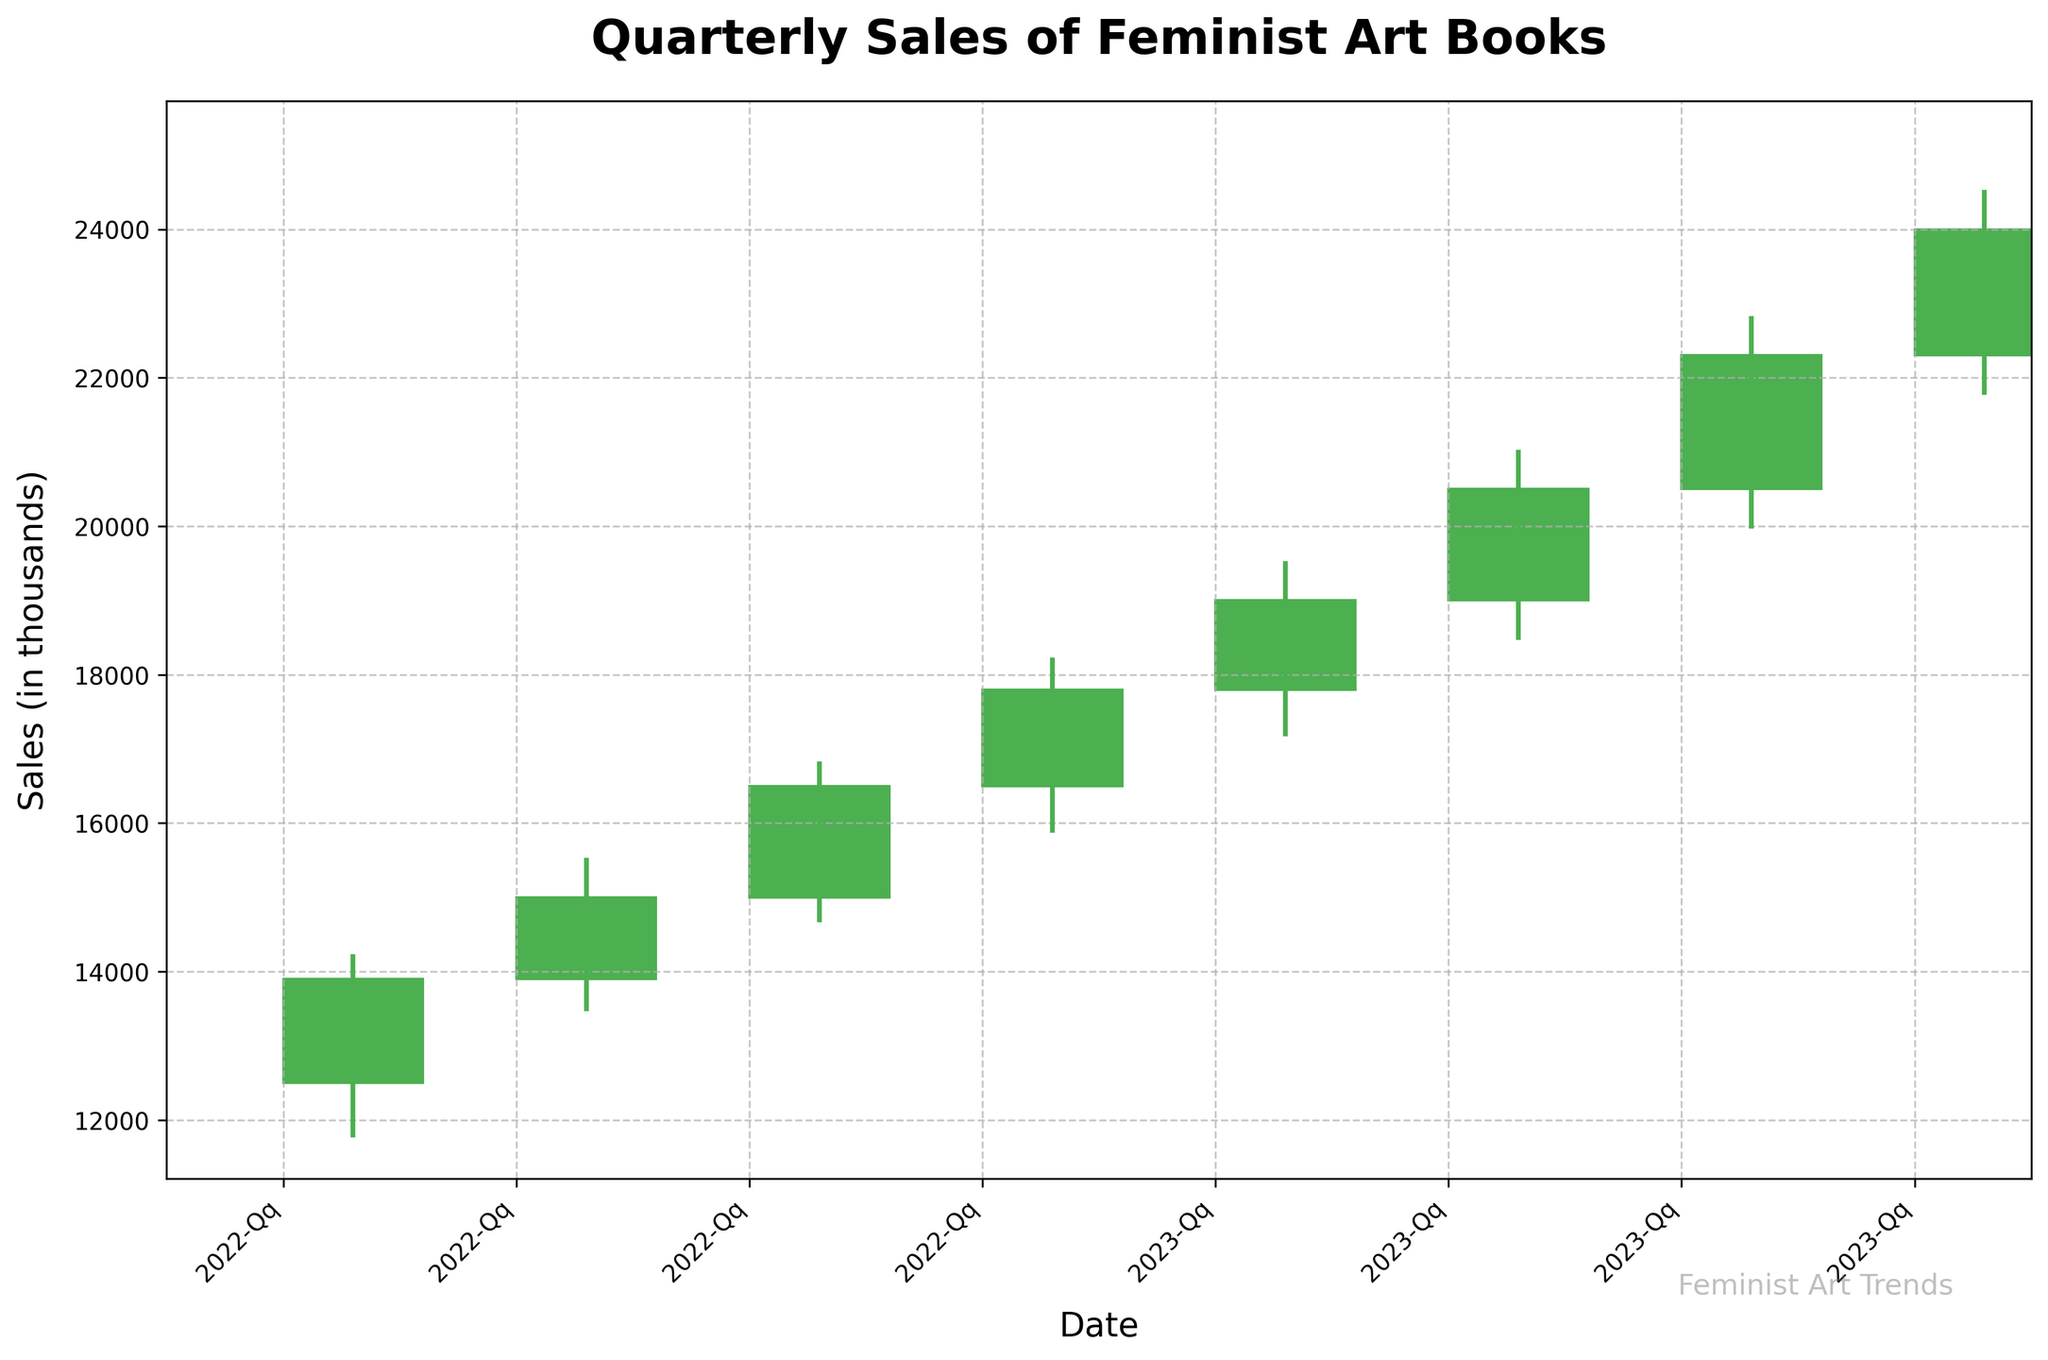What is the title of the chart? The title of the chart is displayed prominently at the top and reads "Quarterly Sales of Feminist Art Books."
Answer: Quarterly Sales of Feminist Art Books How many quarters of data are shown in the chart? The x-axis labels each point on the chart with a date in 'YYYY-QX' format. By counting the labels, you can see there are 8 data points representing 8 quarters.
Answer: 8 During which quarter was the high price the highest? The high price is indicated by the upper end of the vertical line for each quarter. The highest point is reached in 2023-Q4.
Answer: 2023-Q4 What color represents an increase in sales for a quarter? The bodies of the candlesticks are color-coded. A green body represents an increase in sales where the closing value is higher than the opening value. The green used is a shade of '#4CAF50'.
Answer: Green What is the difference between the opening and closing sales figures for 2022-Q1? For 2022-Q1, the opening figure is 12,500 and the closing figure is 13,900. The difference is calculated as 13,900 - 12,500.
Answer: 1,400 Which quarter shows the smallest difference between its high and low sales figures? By checking the high and low figures for each quarter and computing their differences, 2022-Q2 has the smallest difference: 15,500 (high) – 13,500 (low) = 2,000.
Answer: 2022-Q2 What is the average closing sales figure for the eight quarters displayed? Add up all the closing figures (13,900 + 15,000 + 16,500 + 17,800 + 19,000 + 20,500 + 22,300 + 24,000) and divide by 8. The sum is 148,000 so the average is 148,000 / 8.
Answer: 18,500 How does the sales figure in 2023-Q1 compare to that in 2022-Q3? Looking at the closing prices for both quarters, 2023-Q1 has a closing figure of 19,000 and 2022-Q3 has a closing figure of 16,500. Thus, 2023-Q1 has higher sales.
Answer: Higher By how much did the closing sales figure increase from 2022-Q4 to 2023-Q4? The closing figure for 2022-Q4 is 17,800 and for 2023-Q4, it is 24,000. The increase is calculated as 24,000 - 17,800.
Answer: 6,200 Which quarter experienced the highest volatility in sales figures? Volatility can be interpreted as the difference between the high and low figures. 2023-Q4 has high (24,500) and low (21,800), giving a volatility of 2,700, which is higher than any other quarter.
Answer: 2023-Q4 